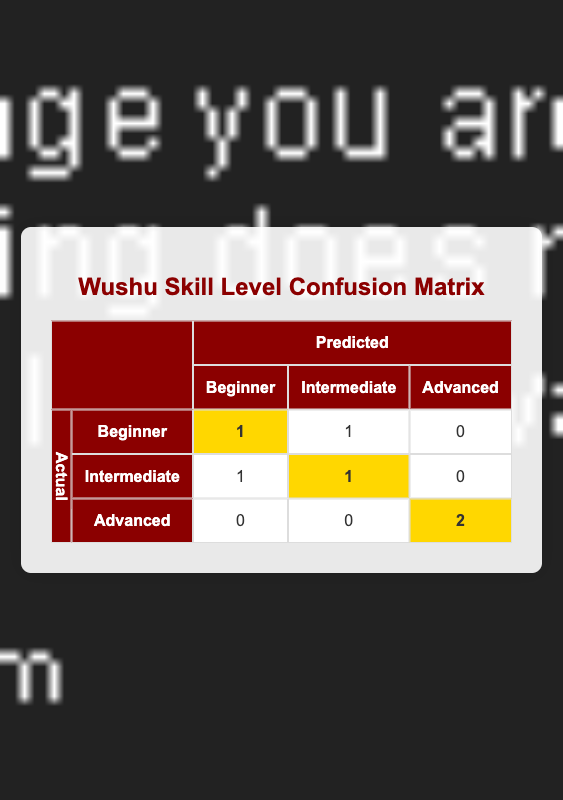What is the number of students predicted as Beginners? In the "Predicted" column under "Beginner", there is one entry that shows the number of students predicted as Beginners, which is 1.
Answer: 1 What is the total number of students categorized as Advanced? Looking at the "Actual" row for "Advanced", we have two occurrences of the predicted category that are highlighted. Therefore, the total number of students categorized as Advanced is 2.
Answer: 2 How many students were actually categorized as Intermediate? In the "Actual" row for "Intermediate", we can see that there is a total of 2 students that are predicted as either Beginners or Intermediate, which points out that 2 students were actually categorized as Intermediate.
Answer: 2 Is it true that no students were incorrectly predicted as Advanced? From the confusion matrix, we can see that for the "Actual" category of Advanced, there were 0 students incorrectly predicted as Advanced, thus the answer is true.
Answer: Yes What is the total number of students who were classified as Beginners? By summing the values from the "Actual" row for Beginners, we have a total of 2 students categorized as Beginners since there are 1 predicted correctly and 1 incorrectly.
Answer: 2 How many students predicted as Intermediate were actually Beginners? In the confusion matrix, looking at the predicted label "Intermediate" for the row labeled "Actual Beginner," the value is 1. Therefore, there is 1 student who was predicted as Intermediate but was actually a Beginner.
Answer: 1 Among the actual Advanced students, how many were correctly predicted? In the "Actual" row for Advanced, it shows "2" highlighted under Predicted Advanced, which means there are 2 students who were correctly predicted as Advanced.
Answer: 2 What percentage of Beginners were correctly predicted? The total number of actual Beginners is 2 (sum of the row labeled Beginner), and only 1 was predicted correctly. Therefore, the percentage is (1/2) * 100 = 50%.
Answer: 50% 